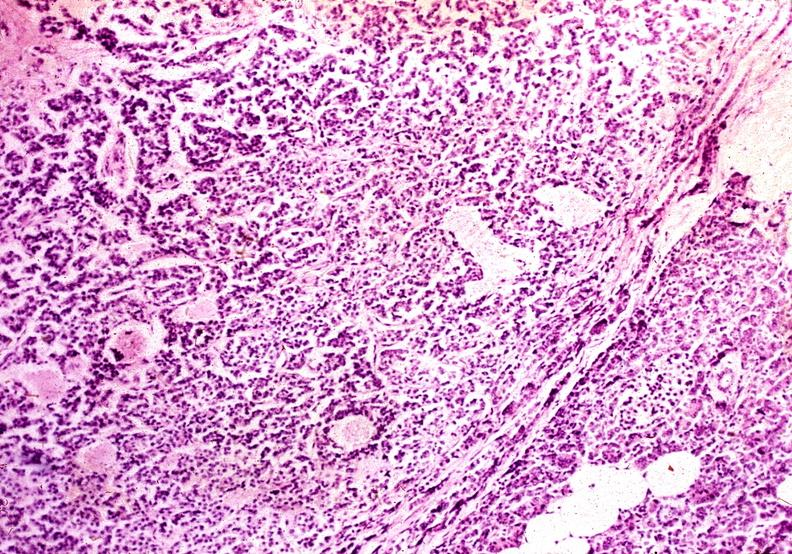s pancreas present?
Answer the question using a single word or phrase. Yes 